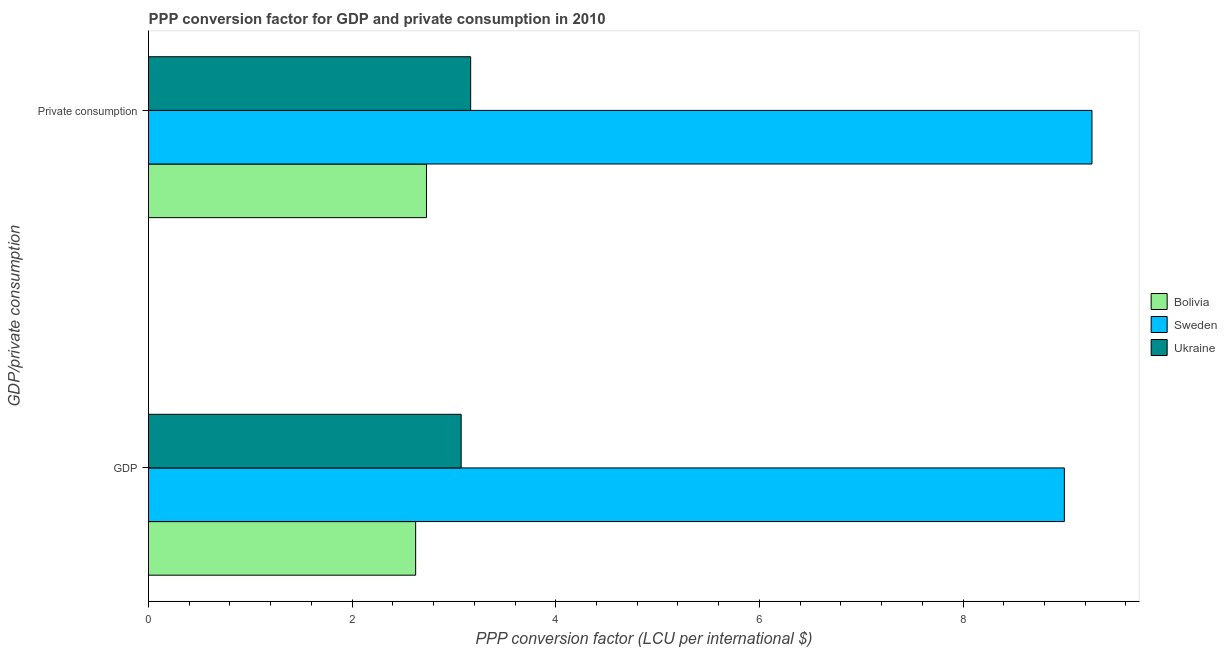How many different coloured bars are there?
Your answer should be compact. 3. How many groups of bars are there?
Offer a very short reply. 2. Are the number of bars on each tick of the Y-axis equal?
Your response must be concise. Yes. How many bars are there on the 1st tick from the bottom?
Your response must be concise. 3. What is the label of the 2nd group of bars from the top?
Provide a short and direct response. GDP. What is the ppp conversion factor for gdp in Bolivia?
Your response must be concise. 2.62. Across all countries, what is the maximum ppp conversion factor for gdp?
Make the answer very short. 9. Across all countries, what is the minimum ppp conversion factor for gdp?
Your response must be concise. 2.62. What is the total ppp conversion factor for gdp in the graph?
Make the answer very short. 14.69. What is the difference between the ppp conversion factor for gdp in Sweden and that in Bolivia?
Give a very brief answer. 6.37. What is the difference between the ppp conversion factor for gdp in Ukraine and the ppp conversion factor for private consumption in Bolivia?
Give a very brief answer. 0.34. What is the average ppp conversion factor for gdp per country?
Offer a very short reply. 4.9. What is the difference between the ppp conversion factor for private consumption and ppp conversion factor for gdp in Ukraine?
Your response must be concise. 0.09. In how many countries, is the ppp conversion factor for gdp greater than 0.8 LCU?
Your answer should be very brief. 3. What is the ratio of the ppp conversion factor for gdp in Sweden to that in Ukraine?
Ensure brevity in your answer.  2.93. Is the ppp conversion factor for private consumption in Bolivia less than that in Ukraine?
Provide a succinct answer. Yes. In how many countries, is the ppp conversion factor for private consumption greater than the average ppp conversion factor for private consumption taken over all countries?
Your answer should be very brief. 1. What does the 1st bar from the top in  Private consumption represents?
Offer a very short reply. Ukraine. What does the 1st bar from the bottom in GDP represents?
Provide a succinct answer. Bolivia. How many bars are there?
Your answer should be compact. 6. What is the difference between two consecutive major ticks on the X-axis?
Make the answer very short. 2. Are the values on the major ticks of X-axis written in scientific E-notation?
Your response must be concise. No. Does the graph contain grids?
Your answer should be very brief. No. How many legend labels are there?
Ensure brevity in your answer.  3. What is the title of the graph?
Your response must be concise. PPP conversion factor for GDP and private consumption in 2010. Does "Haiti" appear as one of the legend labels in the graph?
Offer a terse response. No. What is the label or title of the X-axis?
Your answer should be compact. PPP conversion factor (LCU per international $). What is the label or title of the Y-axis?
Provide a succinct answer. GDP/private consumption. What is the PPP conversion factor (LCU per international $) in Bolivia in GDP?
Make the answer very short. 2.62. What is the PPP conversion factor (LCU per international $) in Sweden in GDP?
Provide a succinct answer. 9. What is the PPP conversion factor (LCU per international $) in Ukraine in GDP?
Your answer should be very brief. 3.07. What is the PPP conversion factor (LCU per international $) in Bolivia in  Private consumption?
Your answer should be compact. 2.73. What is the PPP conversion factor (LCU per international $) of Sweden in  Private consumption?
Your answer should be very brief. 9.27. What is the PPP conversion factor (LCU per international $) in Ukraine in  Private consumption?
Your answer should be compact. 3.16. Across all GDP/private consumption, what is the maximum PPP conversion factor (LCU per international $) of Bolivia?
Ensure brevity in your answer.  2.73. Across all GDP/private consumption, what is the maximum PPP conversion factor (LCU per international $) in Sweden?
Offer a terse response. 9.27. Across all GDP/private consumption, what is the maximum PPP conversion factor (LCU per international $) of Ukraine?
Give a very brief answer. 3.16. Across all GDP/private consumption, what is the minimum PPP conversion factor (LCU per international $) in Bolivia?
Provide a short and direct response. 2.62. Across all GDP/private consumption, what is the minimum PPP conversion factor (LCU per international $) of Sweden?
Offer a very short reply. 9. Across all GDP/private consumption, what is the minimum PPP conversion factor (LCU per international $) in Ukraine?
Make the answer very short. 3.07. What is the total PPP conversion factor (LCU per international $) of Bolivia in the graph?
Your answer should be compact. 5.35. What is the total PPP conversion factor (LCU per international $) in Sweden in the graph?
Your answer should be compact. 18.26. What is the total PPP conversion factor (LCU per international $) of Ukraine in the graph?
Provide a succinct answer. 6.23. What is the difference between the PPP conversion factor (LCU per international $) in Bolivia in GDP and that in  Private consumption?
Your answer should be compact. -0.11. What is the difference between the PPP conversion factor (LCU per international $) of Sweden in GDP and that in  Private consumption?
Offer a terse response. -0.27. What is the difference between the PPP conversion factor (LCU per international $) of Ukraine in GDP and that in  Private consumption?
Your answer should be compact. -0.09. What is the difference between the PPP conversion factor (LCU per international $) in Bolivia in GDP and the PPP conversion factor (LCU per international $) in Sweden in  Private consumption?
Keep it short and to the point. -6.64. What is the difference between the PPP conversion factor (LCU per international $) of Bolivia in GDP and the PPP conversion factor (LCU per international $) of Ukraine in  Private consumption?
Provide a succinct answer. -0.54. What is the difference between the PPP conversion factor (LCU per international $) in Sweden in GDP and the PPP conversion factor (LCU per international $) in Ukraine in  Private consumption?
Make the answer very short. 5.83. What is the average PPP conversion factor (LCU per international $) in Bolivia per GDP/private consumption?
Keep it short and to the point. 2.68. What is the average PPP conversion factor (LCU per international $) in Sweden per GDP/private consumption?
Provide a succinct answer. 9.13. What is the average PPP conversion factor (LCU per international $) of Ukraine per GDP/private consumption?
Make the answer very short. 3.12. What is the difference between the PPP conversion factor (LCU per international $) of Bolivia and PPP conversion factor (LCU per international $) of Sweden in GDP?
Ensure brevity in your answer.  -6.37. What is the difference between the PPP conversion factor (LCU per international $) of Bolivia and PPP conversion factor (LCU per international $) of Ukraine in GDP?
Your response must be concise. -0.45. What is the difference between the PPP conversion factor (LCU per international $) in Sweden and PPP conversion factor (LCU per international $) in Ukraine in GDP?
Your response must be concise. 5.92. What is the difference between the PPP conversion factor (LCU per international $) of Bolivia and PPP conversion factor (LCU per international $) of Sweden in  Private consumption?
Offer a very short reply. -6.54. What is the difference between the PPP conversion factor (LCU per international $) of Bolivia and PPP conversion factor (LCU per international $) of Ukraine in  Private consumption?
Provide a short and direct response. -0.43. What is the difference between the PPP conversion factor (LCU per international $) in Sweden and PPP conversion factor (LCU per international $) in Ukraine in  Private consumption?
Provide a short and direct response. 6.1. What is the ratio of the PPP conversion factor (LCU per international $) in Bolivia in GDP to that in  Private consumption?
Ensure brevity in your answer.  0.96. What is the ratio of the PPP conversion factor (LCU per international $) in Sweden in GDP to that in  Private consumption?
Provide a succinct answer. 0.97. What is the ratio of the PPP conversion factor (LCU per international $) of Ukraine in GDP to that in  Private consumption?
Provide a succinct answer. 0.97. What is the difference between the highest and the second highest PPP conversion factor (LCU per international $) in Bolivia?
Offer a very short reply. 0.11. What is the difference between the highest and the second highest PPP conversion factor (LCU per international $) of Sweden?
Offer a very short reply. 0.27. What is the difference between the highest and the second highest PPP conversion factor (LCU per international $) in Ukraine?
Your answer should be very brief. 0.09. What is the difference between the highest and the lowest PPP conversion factor (LCU per international $) of Bolivia?
Ensure brevity in your answer.  0.11. What is the difference between the highest and the lowest PPP conversion factor (LCU per international $) of Sweden?
Offer a very short reply. 0.27. What is the difference between the highest and the lowest PPP conversion factor (LCU per international $) of Ukraine?
Offer a very short reply. 0.09. 